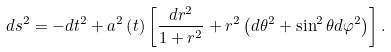<formula> <loc_0><loc_0><loc_500><loc_500>d s ^ { 2 } = - d t ^ { 2 } + a ^ { 2 } \left ( t \right ) \left [ \frac { d r ^ { 2 } } { 1 + r ^ { 2 } } + r ^ { 2 } \left ( d \theta ^ { 2 } + \sin ^ { 2 } \theta d \varphi ^ { 2 } \right ) \right ] .</formula> 